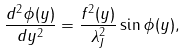Convert formula to latex. <formula><loc_0><loc_0><loc_500><loc_500>\frac { d ^ { 2 } \phi ( y ) } { d y ^ { 2 } } = \frac { f ^ { 2 } ( y ) } { \lambda _ { J } ^ { 2 } } \sin \phi ( y ) ,</formula> 